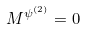Convert formula to latex. <formula><loc_0><loc_0><loc_500><loc_500>M ^ { \psi ^ { ( 2 ) } } = 0</formula> 